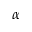<formula> <loc_0><loc_0><loc_500><loc_500>\alpha</formula> 